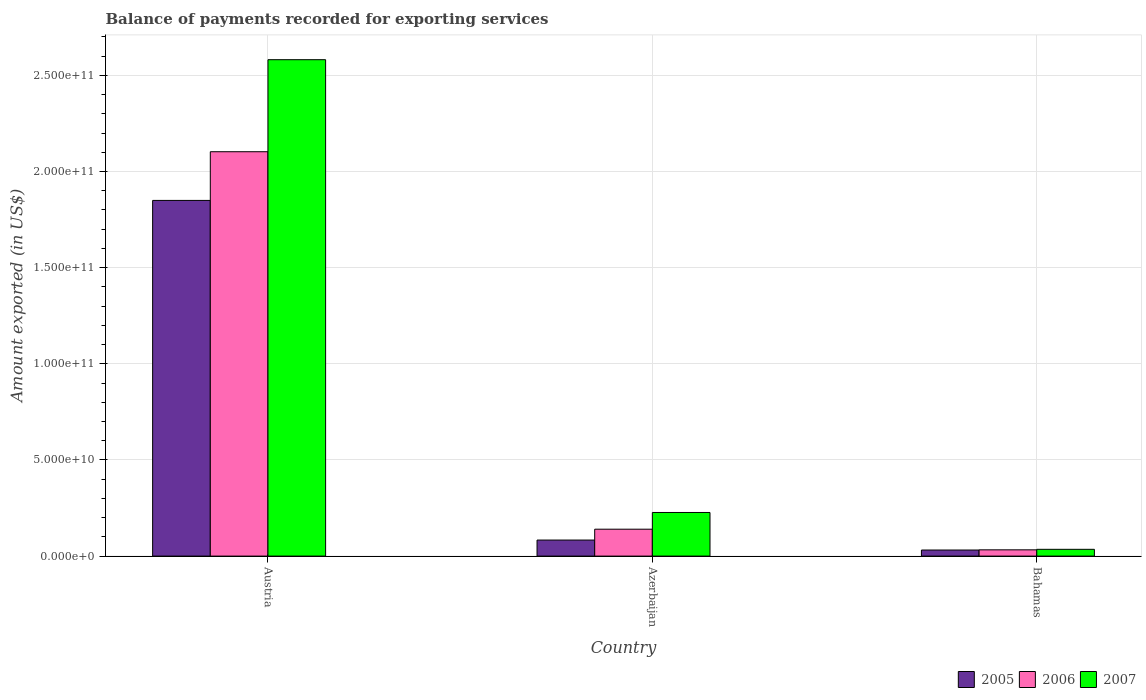How many different coloured bars are there?
Offer a terse response. 3. How many groups of bars are there?
Give a very brief answer. 3. Are the number of bars per tick equal to the number of legend labels?
Offer a very short reply. Yes. What is the label of the 3rd group of bars from the left?
Offer a terse response. Bahamas. What is the amount exported in 2006 in Bahamas?
Provide a succinct answer. 3.26e+09. Across all countries, what is the maximum amount exported in 2006?
Offer a terse response. 2.10e+11. Across all countries, what is the minimum amount exported in 2006?
Your answer should be compact. 3.26e+09. In which country was the amount exported in 2007 maximum?
Your answer should be very brief. Austria. In which country was the amount exported in 2006 minimum?
Provide a succinct answer. Bahamas. What is the total amount exported in 2006 in the graph?
Your answer should be compact. 2.28e+11. What is the difference between the amount exported in 2006 in Austria and that in Bahamas?
Keep it short and to the point. 2.07e+11. What is the difference between the amount exported in 2006 in Austria and the amount exported in 2007 in Azerbaijan?
Give a very brief answer. 1.88e+11. What is the average amount exported in 2007 per country?
Make the answer very short. 9.48e+1. What is the difference between the amount exported of/in 2005 and amount exported of/in 2007 in Azerbaijan?
Make the answer very short. -1.43e+1. In how many countries, is the amount exported in 2006 greater than 60000000000 US$?
Offer a very short reply. 1. What is the ratio of the amount exported in 2007 in Azerbaijan to that in Bahamas?
Ensure brevity in your answer.  6.44. Is the amount exported in 2005 in Austria less than that in Bahamas?
Offer a terse response. No. Is the difference between the amount exported in 2005 in Austria and Bahamas greater than the difference between the amount exported in 2007 in Austria and Bahamas?
Your response must be concise. No. What is the difference between the highest and the second highest amount exported in 2006?
Provide a short and direct response. -1.96e+11. What is the difference between the highest and the lowest amount exported in 2006?
Your answer should be compact. 2.07e+11. What does the 2nd bar from the right in Bahamas represents?
Your response must be concise. 2006. How many bars are there?
Give a very brief answer. 9. Are the values on the major ticks of Y-axis written in scientific E-notation?
Offer a very short reply. Yes. Does the graph contain any zero values?
Make the answer very short. No. How many legend labels are there?
Your answer should be very brief. 3. What is the title of the graph?
Provide a short and direct response. Balance of payments recorded for exporting services. What is the label or title of the X-axis?
Ensure brevity in your answer.  Country. What is the label or title of the Y-axis?
Your answer should be very brief. Amount exported (in US$). What is the Amount exported (in US$) in 2005 in Austria?
Your answer should be compact. 1.85e+11. What is the Amount exported (in US$) of 2006 in Austria?
Your answer should be very brief. 2.10e+11. What is the Amount exported (in US$) in 2007 in Austria?
Give a very brief answer. 2.58e+11. What is the Amount exported (in US$) in 2005 in Azerbaijan?
Provide a short and direct response. 8.34e+09. What is the Amount exported (in US$) in 2006 in Azerbaijan?
Give a very brief answer. 1.40e+1. What is the Amount exported (in US$) of 2007 in Azerbaijan?
Keep it short and to the point. 2.27e+1. What is the Amount exported (in US$) in 2005 in Bahamas?
Provide a succinct answer. 3.16e+09. What is the Amount exported (in US$) in 2006 in Bahamas?
Provide a succinct answer. 3.26e+09. What is the Amount exported (in US$) of 2007 in Bahamas?
Make the answer very short. 3.52e+09. Across all countries, what is the maximum Amount exported (in US$) in 2005?
Provide a succinct answer. 1.85e+11. Across all countries, what is the maximum Amount exported (in US$) in 2006?
Keep it short and to the point. 2.10e+11. Across all countries, what is the maximum Amount exported (in US$) in 2007?
Give a very brief answer. 2.58e+11. Across all countries, what is the minimum Amount exported (in US$) in 2005?
Provide a succinct answer. 3.16e+09. Across all countries, what is the minimum Amount exported (in US$) of 2006?
Make the answer very short. 3.26e+09. Across all countries, what is the minimum Amount exported (in US$) in 2007?
Give a very brief answer. 3.52e+09. What is the total Amount exported (in US$) of 2005 in the graph?
Provide a short and direct response. 1.96e+11. What is the total Amount exported (in US$) of 2006 in the graph?
Your response must be concise. 2.28e+11. What is the total Amount exported (in US$) in 2007 in the graph?
Offer a very short reply. 2.84e+11. What is the difference between the Amount exported (in US$) in 2005 in Austria and that in Azerbaijan?
Your response must be concise. 1.77e+11. What is the difference between the Amount exported (in US$) of 2006 in Austria and that in Azerbaijan?
Provide a succinct answer. 1.96e+11. What is the difference between the Amount exported (in US$) in 2007 in Austria and that in Azerbaijan?
Keep it short and to the point. 2.35e+11. What is the difference between the Amount exported (in US$) in 2005 in Austria and that in Bahamas?
Give a very brief answer. 1.82e+11. What is the difference between the Amount exported (in US$) of 2006 in Austria and that in Bahamas?
Provide a short and direct response. 2.07e+11. What is the difference between the Amount exported (in US$) of 2007 in Austria and that in Bahamas?
Keep it short and to the point. 2.55e+11. What is the difference between the Amount exported (in US$) of 2005 in Azerbaijan and that in Bahamas?
Your response must be concise. 5.18e+09. What is the difference between the Amount exported (in US$) of 2006 in Azerbaijan and that in Bahamas?
Your answer should be very brief. 1.07e+1. What is the difference between the Amount exported (in US$) in 2007 in Azerbaijan and that in Bahamas?
Give a very brief answer. 1.92e+1. What is the difference between the Amount exported (in US$) of 2005 in Austria and the Amount exported (in US$) of 2006 in Azerbaijan?
Keep it short and to the point. 1.71e+11. What is the difference between the Amount exported (in US$) in 2005 in Austria and the Amount exported (in US$) in 2007 in Azerbaijan?
Offer a terse response. 1.62e+11. What is the difference between the Amount exported (in US$) in 2006 in Austria and the Amount exported (in US$) in 2007 in Azerbaijan?
Provide a succinct answer. 1.88e+11. What is the difference between the Amount exported (in US$) in 2005 in Austria and the Amount exported (in US$) in 2006 in Bahamas?
Offer a very short reply. 1.82e+11. What is the difference between the Amount exported (in US$) of 2005 in Austria and the Amount exported (in US$) of 2007 in Bahamas?
Give a very brief answer. 1.81e+11. What is the difference between the Amount exported (in US$) in 2006 in Austria and the Amount exported (in US$) in 2007 in Bahamas?
Offer a very short reply. 2.07e+11. What is the difference between the Amount exported (in US$) in 2005 in Azerbaijan and the Amount exported (in US$) in 2006 in Bahamas?
Give a very brief answer. 5.08e+09. What is the difference between the Amount exported (in US$) of 2005 in Azerbaijan and the Amount exported (in US$) of 2007 in Bahamas?
Provide a succinct answer. 4.82e+09. What is the difference between the Amount exported (in US$) in 2006 in Azerbaijan and the Amount exported (in US$) in 2007 in Bahamas?
Offer a terse response. 1.05e+1. What is the average Amount exported (in US$) of 2005 per country?
Your answer should be very brief. 6.55e+1. What is the average Amount exported (in US$) of 2006 per country?
Your answer should be compact. 7.59e+1. What is the average Amount exported (in US$) in 2007 per country?
Offer a very short reply. 9.48e+1. What is the difference between the Amount exported (in US$) of 2005 and Amount exported (in US$) of 2006 in Austria?
Make the answer very short. -2.53e+1. What is the difference between the Amount exported (in US$) in 2005 and Amount exported (in US$) in 2007 in Austria?
Make the answer very short. -7.32e+1. What is the difference between the Amount exported (in US$) in 2006 and Amount exported (in US$) in 2007 in Austria?
Your response must be concise. -4.79e+1. What is the difference between the Amount exported (in US$) of 2005 and Amount exported (in US$) of 2006 in Azerbaijan?
Make the answer very short. -5.65e+09. What is the difference between the Amount exported (in US$) of 2005 and Amount exported (in US$) of 2007 in Azerbaijan?
Give a very brief answer. -1.43e+1. What is the difference between the Amount exported (in US$) of 2006 and Amount exported (in US$) of 2007 in Azerbaijan?
Your answer should be compact. -8.69e+09. What is the difference between the Amount exported (in US$) in 2005 and Amount exported (in US$) in 2006 in Bahamas?
Your answer should be very brief. -1.02e+08. What is the difference between the Amount exported (in US$) in 2005 and Amount exported (in US$) in 2007 in Bahamas?
Make the answer very short. -3.65e+08. What is the difference between the Amount exported (in US$) of 2006 and Amount exported (in US$) of 2007 in Bahamas?
Offer a very short reply. -2.63e+08. What is the ratio of the Amount exported (in US$) in 2005 in Austria to that in Azerbaijan?
Provide a short and direct response. 22.18. What is the ratio of the Amount exported (in US$) in 2006 in Austria to that in Azerbaijan?
Keep it short and to the point. 15.03. What is the ratio of the Amount exported (in US$) of 2007 in Austria to that in Azerbaijan?
Provide a short and direct response. 11.38. What is the ratio of the Amount exported (in US$) of 2005 in Austria to that in Bahamas?
Provide a short and direct response. 58.59. What is the ratio of the Amount exported (in US$) in 2006 in Austria to that in Bahamas?
Your response must be concise. 64.53. What is the ratio of the Amount exported (in US$) in 2007 in Austria to that in Bahamas?
Provide a succinct answer. 73.29. What is the ratio of the Amount exported (in US$) of 2005 in Azerbaijan to that in Bahamas?
Your answer should be very brief. 2.64. What is the ratio of the Amount exported (in US$) of 2006 in Azerbaijan to that in Bahamas?
Give a very brief answer. 4.29. What is the ratio of the Amount exported (in US$) of 2007 in Azerbaijan to that in Bahamas?
Offer a very short reply. 6.44. What is the difference between the highest and the second highest Amount exported (in US$) of 2005?
Make the answer very short. 1.77e+11. What is the difference between the highest and the second highest Amount exported (in US$) in 2006?
Give a very brief answer. 1.96e+11. What is the difference between the highest and the second highest Amount exported (in US$) of 2007?
Ensure brevity in your answer.  2.35e+11. What is the difference between the highest and the lowest Amount exported (in US$) of 2005?
Make the answer very short. 1.82e+11. What is the difference between the highest and the lowest Amount exported (in US$) in 2006?
Your response must be concise. 2.07e+11. What is the difference between the highest and the lowest Amount exported (in US$) of 2007?
Your response must be concise. 2.55e+11. 